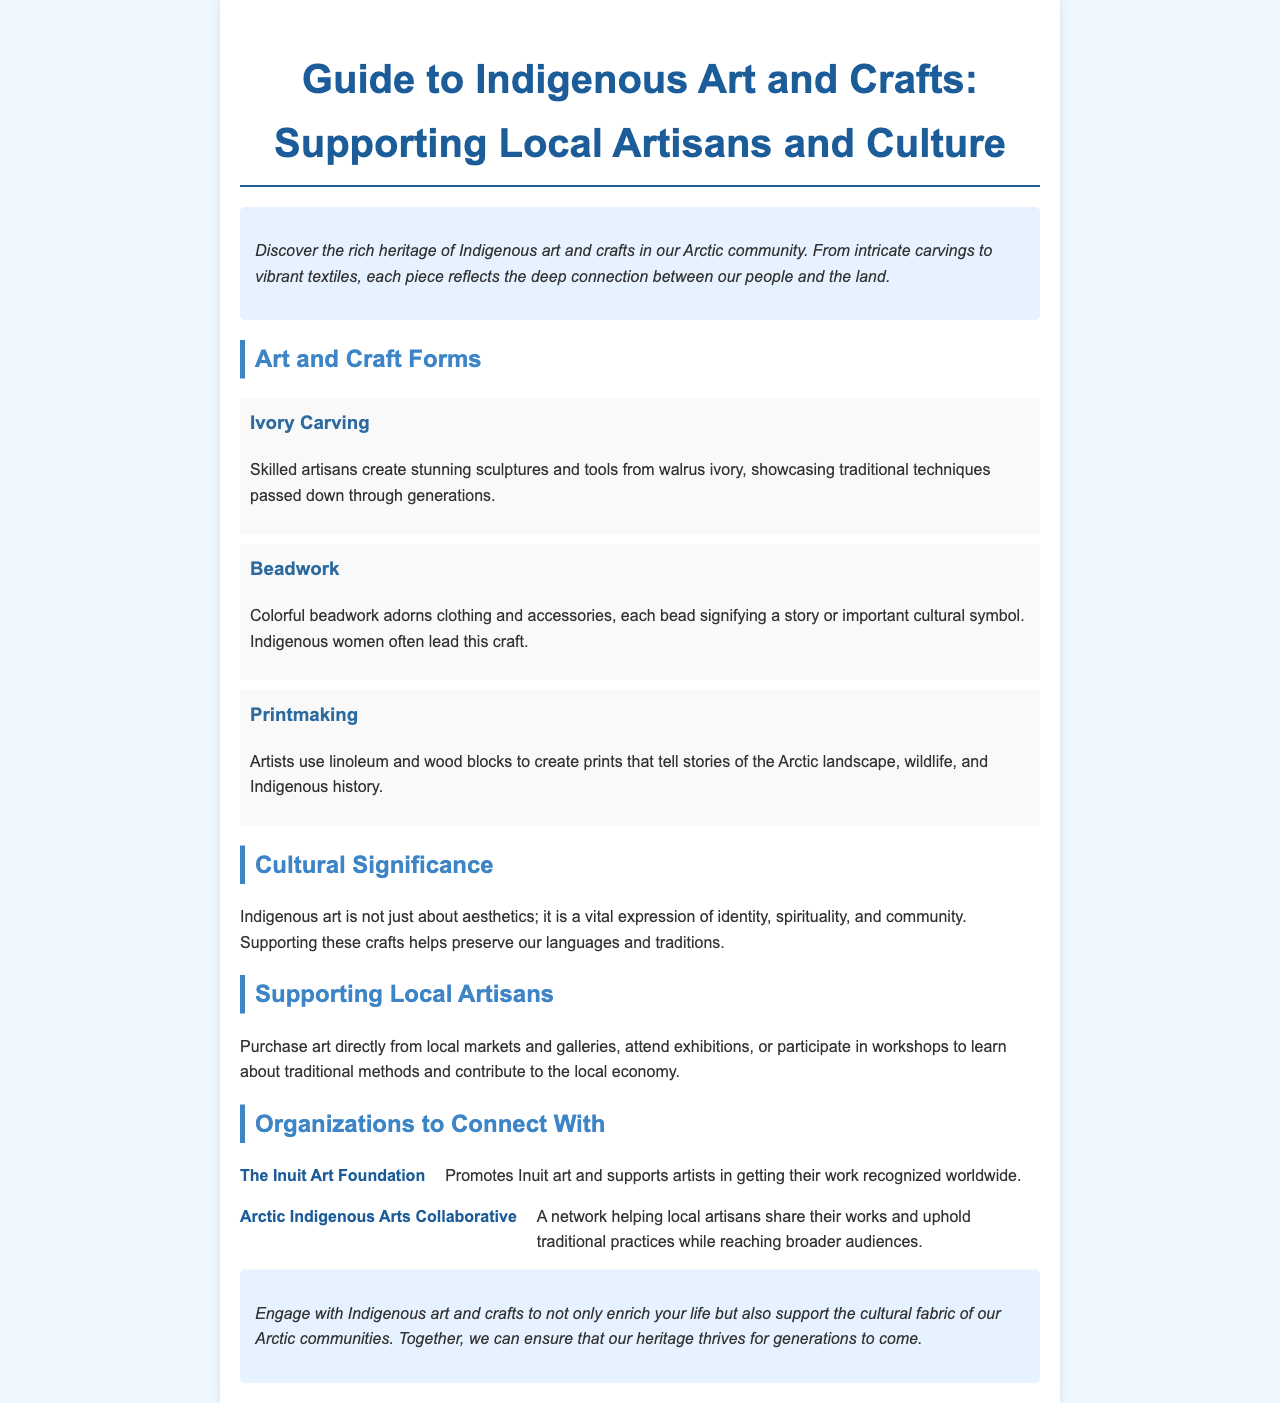what is the title of the brochure? The title is the heading of the document, introducing the main topic.
Answer: Guide to Indigenous Art and Crafts: Supporting Local Artisans and Culture how many art forms are mentioned? The document lists the different art forms under the section "Art and Craft Forms."
Answer: 3 what is one material used in ivory carving? The document specifies the material used in ivory carving.
Answer: walrus ivory who supports Inuit artists? The document includes a section with organizations that support local artisans.
Answer: The Inuit Art Foundation what do colorful beads in beadwork symbolize? The document explains the cultural significance of the beads used in beadwork.
Answer: a story or important cultural symbol why is supporting Indigenous crafts important? The document discusses the cultural significance of Indigenous art and crafts.
Answer: preserve our languages and traditions which organization helps local artisans share their works? The document mentions organizations that assist local artisans in their endeavors.
Answer: Arctic Indigenous Arts Collaborative what type of art uses linoleum and wood blocks? The document categorizes different forms of art and craft.
Answer: Printmaking 